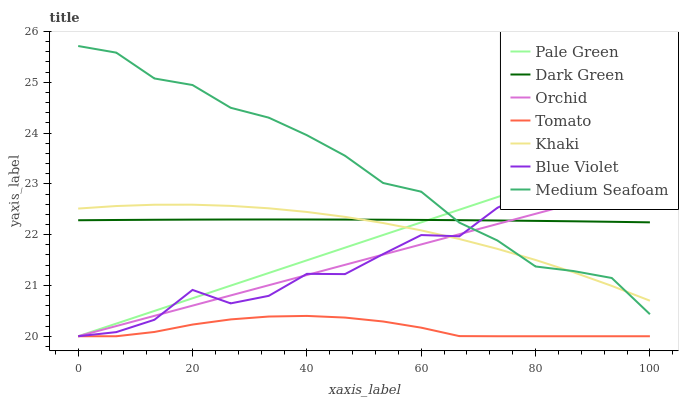Does Tomato have the minimum area under the curve?
Answer yes or no. Yes. Does Medium Seafoam have the maximum area under the curve?
Answer yes or no. Yes. Does Khaki have the minimum area under the curve?
Answer yes or no. No. Does Khaki have the maximum area under the curve?
Answer yes or no. No. Is Pale Green the smoothest?
Answer yes or no. Yes. Is Blue Violet the roughest?
Answer yes or no. Yes. Is Khaki the smoothest?
Answer yes or no. No. Is Khaki the roughest?
Answer yes or no. No. Does Tomato have the lowest value?
Answer yes or no. Yes. Does Khaki have the lowest value?
Answer yes or no. No. Does Medium Seafoam have the highest value?
Answer yes or no. Yes. Does Khaki have the highest value?
Answer yes or no. No. Is Tomato less than Dark Green?
Answer yes or no. Yes. Is Khaki greater than Tomato?
Answer yes or no. Yes. Does Khaki intersect Blue Violet?
Answer yes or no. Yes. Is Khaki less than Blue Violet?
Answer yes or no. No. Is Khaki greater than Blue Violet?
Answer yes or no. No. Does Tomato intersect Dark Green?
Answer yes or no. No. 